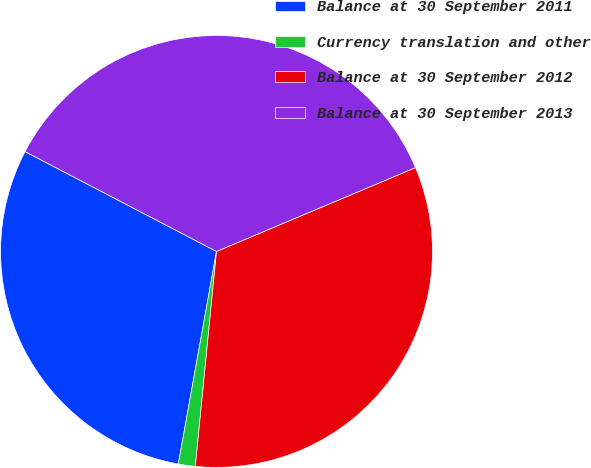<chart> <loc_0><loc_0><loc_500><loc_500><pie_chart><fcel>Balance at 30 September 2011<fcel>Currency translation and other<fcel>Balance at 30 September 2012<fcel>Balance at 30 September 2013<nl><fcel>29.82%<fcel>1.27%<fcel>32.91%<fcel>36.0%<nl></chart> 